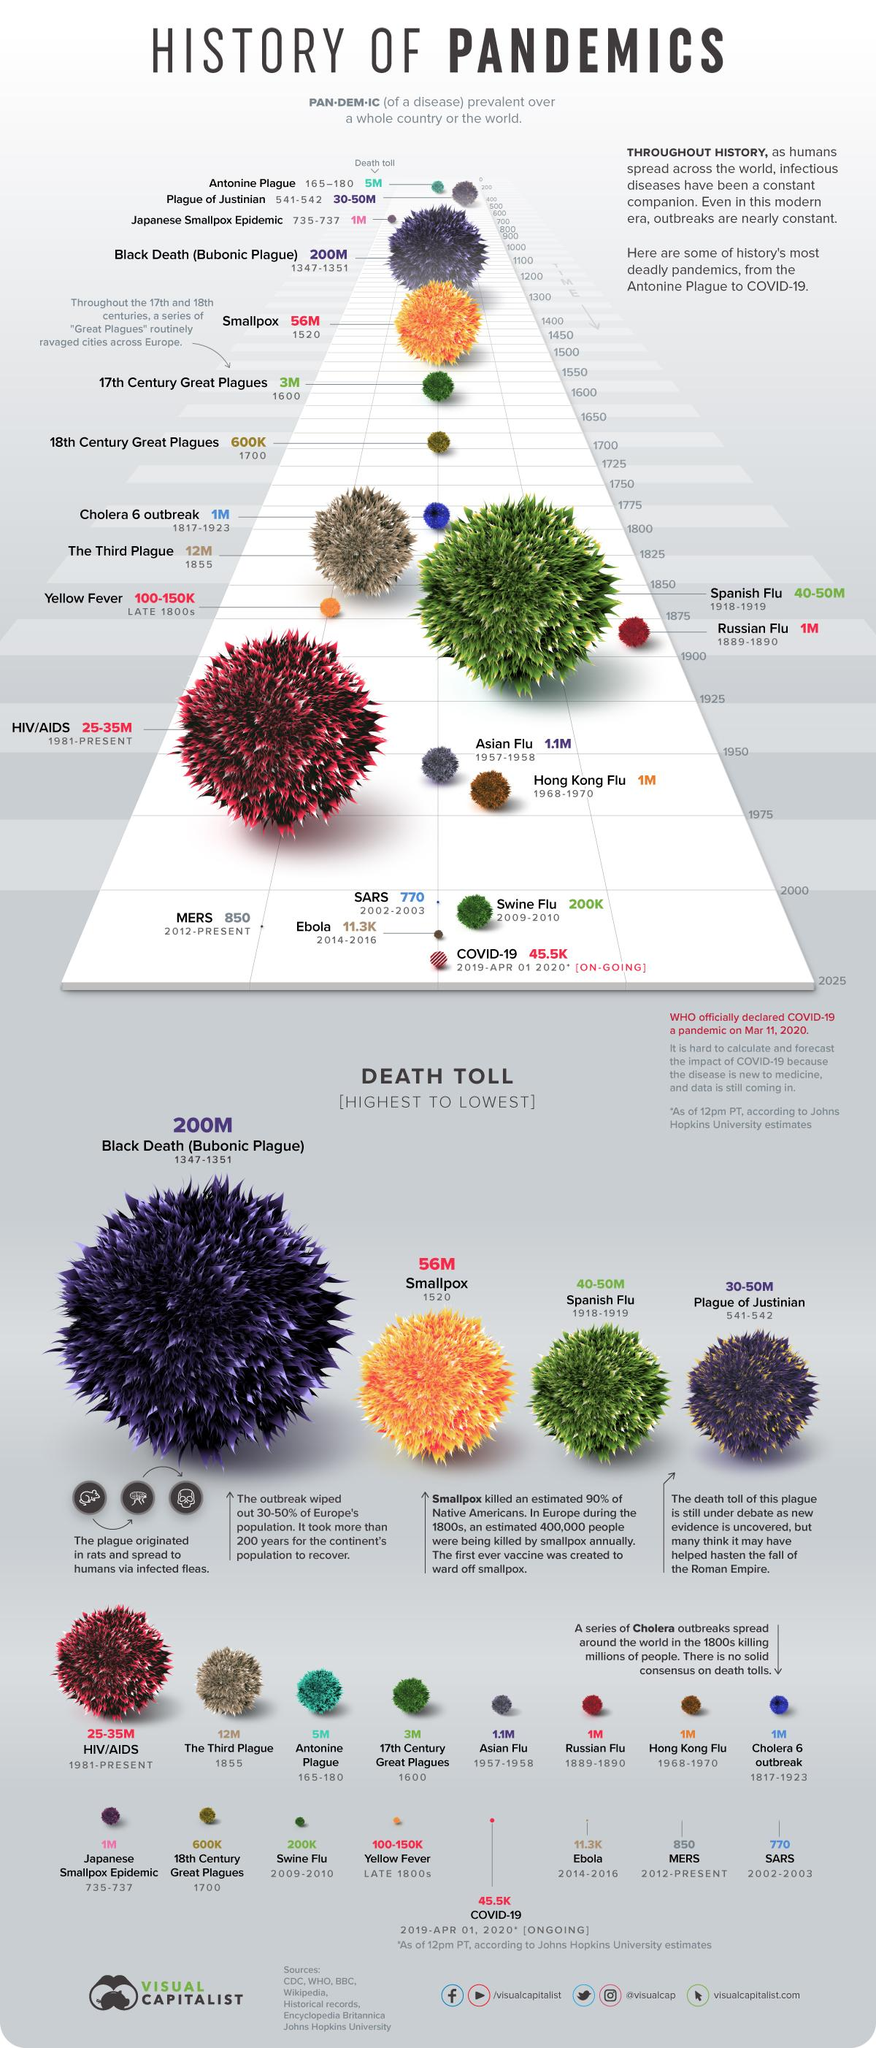Point out several critical features in this image. The swine flu outbreak occurred between the years 2009 and 2010. The Third Plague, responsible for the death of 12 million people in 1855, was a disease outbreak. The disease outbreak that occurred in the late 1800s was Yellow Fever. The Hong Kong Flu outbreak occurred between 1968 and 1970. The Russian Flu is believed to have caused the deaths of approximately 1 million people. 